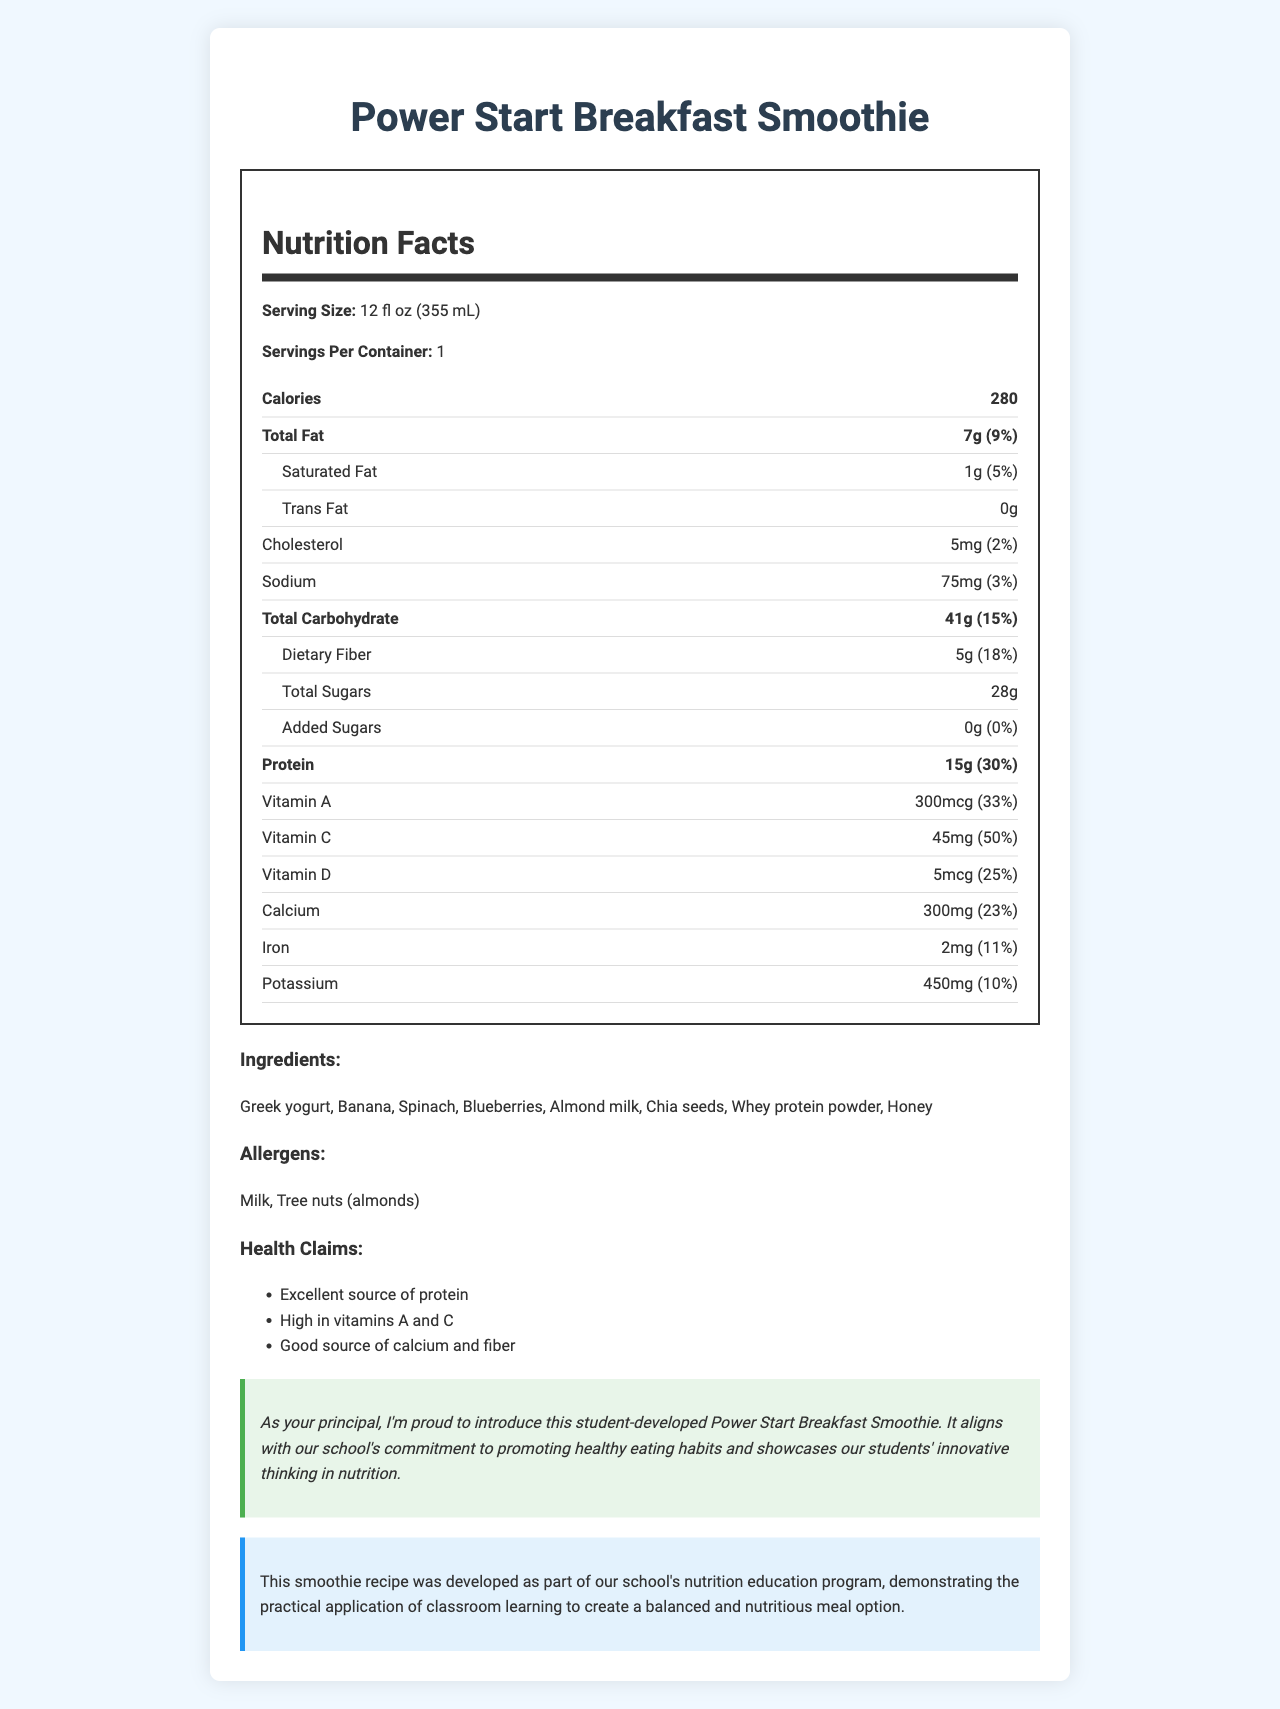what is the serving size of the Power Start Breakfast Smoothie? The serving size is explicitly stated under the "Nutrition Facts" section of the document.
Answer: 12 fl oz (355 mL) how many calories are in one serving of the smoothie? The calorie count per serving is listed in the "Nutrition Facts" section.
Answer: 280 calories name three ingredients in the Power Start Breakfast Smoothie. These ingredients are listed in the "Ingredients" section of the document.
Answer: Greek yogurt, Banana, Spinach what is the total fat content and its percent daily value? This information is specified under the "Total Fat" row in the "Nutrition Facts" section.
Answer: 7g, 9% what are the health claims mentioned for the smoothie? These health claims are listed in the "Health Claims" section.
Answer: Excellent source of protein, High in vitamins A and C, Good source of calcium and fiber what allergens are present in the smoothie? The "Allergens" section lists these components.
Answer: Milk, Tree nuts (almonds) which vitamin has the highest percent daily value in the smoothie? A. Vitamin A B. Vitamin C C. Vitamin D D. Calcium The "Nutrition Facts" indicates that Vitamin C has a percent daily value of 50%, which is the highest among the vitamins listed.
Answer: B. Vitamin C how much protein does this smoothie contain? A. 10g B. 12g C. 15g D. 18g The "Nutrition Facts" section lists 15g of protein per serving.
Answer: C. 15g does the smoothie contain added sugars? The "Nutrition Facts" section shows that the amount of added sugars is 0g.
Answer: No is this smoothie a good source of fiber? The "Health Claims" section states that the smoothie is a good source of fiber.
Answer: Yes summarize the main idea of the document. The document provides a comprehensive overview of the Power Start Breakfast Smoothie, emphasizing its nutritional benefits and its role in promoting healthy eating habits among students.
Answer: The document presents the nutrition facts for the Power Start Breakfast Smoothie, highlighting its high protein and vitamin content. It includes detailed nutritional information, ingredients, allergens, health claims, and endorsements from the school principal, signifying the smoothie’s alignment with the school’s nutrition education program. what percentage of daily value of calcium is in the smoothie? The "Nutrition Facts" lists the calcium content as 300mg, which corresponds to 23% of the daily value.
Answer: 23% what is the main ingredient that contributes to the protein content? While multiple ingredients contribute, using whey protein powder is a primary source of protein, as indicated in the "Ingredients" section.
Answer: Whey protein powder how is the principal involved with the Power Start Breakfast Smoothie? This information is found in the "Principal Note" section.
Answer: The principal endorses the smoothie and is proud of its alignment with the school's healthy eating initiative, showcasing students' innovative thinking in nutrition. what inspired the development of this smoothie recipe? The "Education Note" states that the recipe arose from the school’s initiative to apply classroom learning to nutritious meal creation.
Answer: The smoothie recipe was developed as part of the school's nutrition education program. what is the total carbohydrate content of the smoothie per serving? The "Nutrition Facts" section states that total carbohydrates per serving amount to 41g.
Answer: 41g how much saturated fat does the smoothie contain? The "Nutrition Facts" section lists 1g of saturated fat per serving.
Answer: 1g what role does honey play in this smoothie? While honey is listed as an ingredient, there is no specific mention of its role or the quantity used within the document.
Answer: Not enough information 